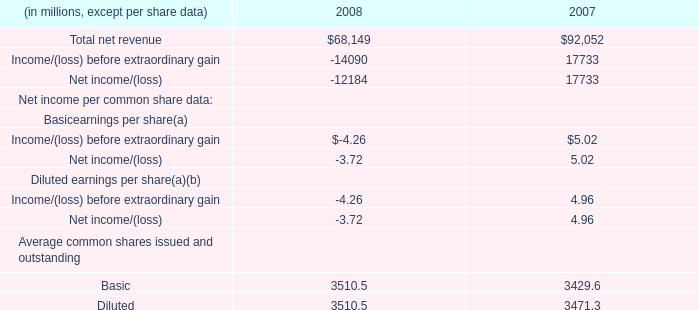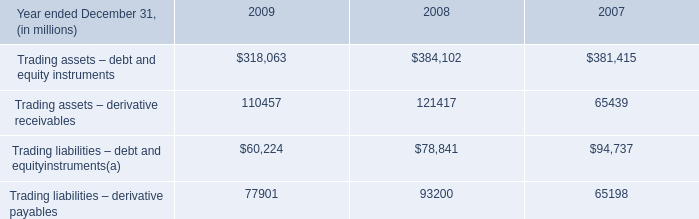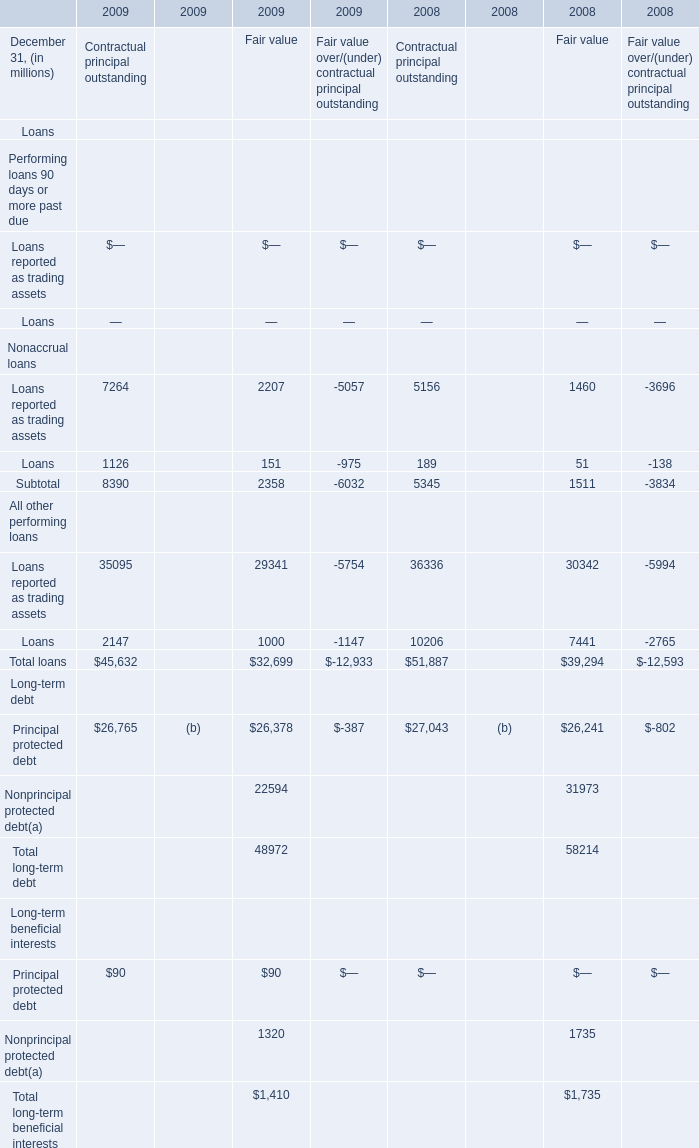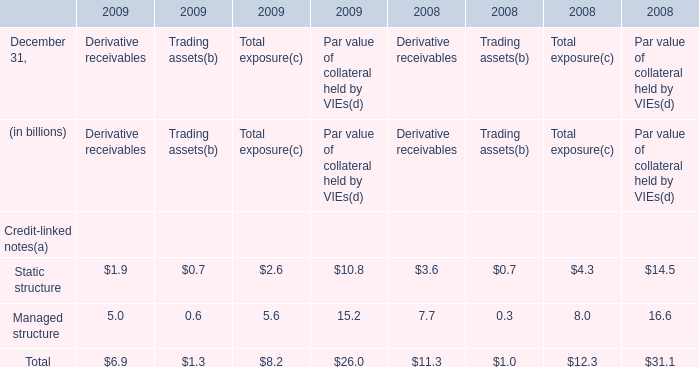What is the sum of the Loans reported as trading assets of All other performing loans in the years where Loans of Nonaccrual loans greater than 0 ? (in million) 
Computations: (((((35095 + 29341) - 5754) + 36336) + 30342) - 5994)
Answer: 119366.0. 